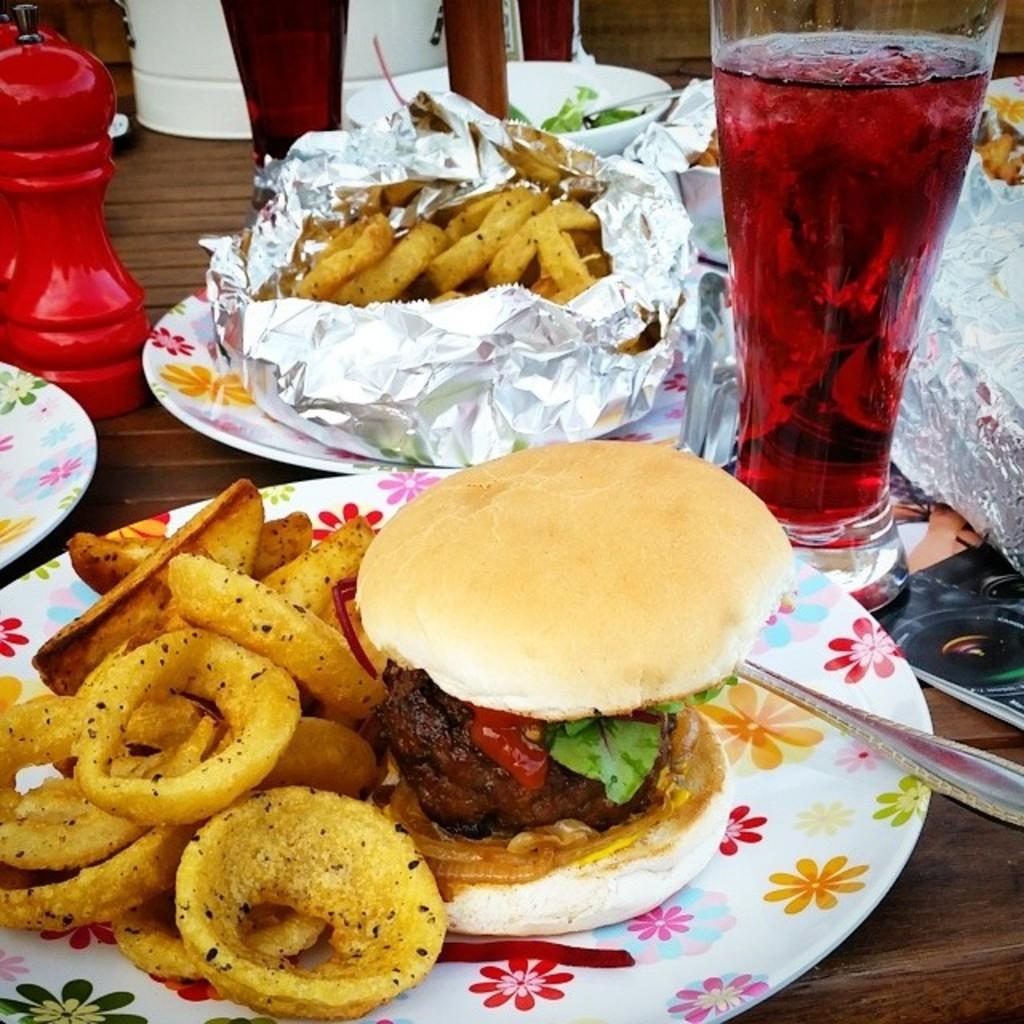What type of tableware can be seen in the image? There are glasses, bottles, plates, vessels, and spoons in the image. What else is present in the image besides tableware? There are food items in the image. Can you describe the lighting conditions in the image? The image was taken during the day, so there is natural light present. How many bags are visible in the image? There are no bags present in the image. What type of toothbrush is being exchanged between the people in the image? There are no people or toothbrushes present in the image. 